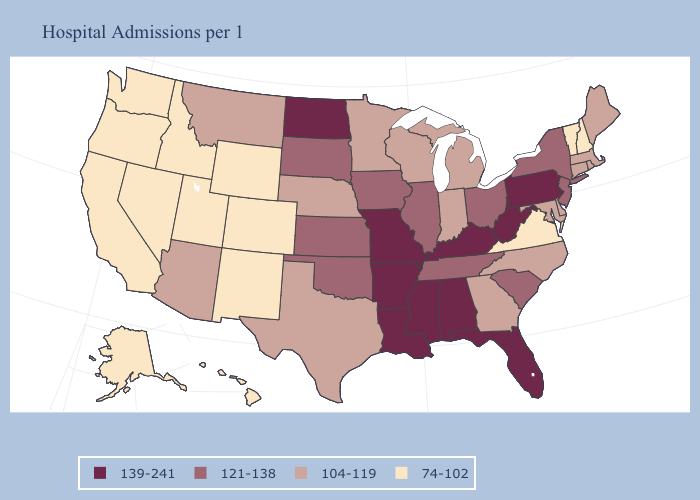Does the map have missing data?
Quick response, please. No. Name the states that have a value in the range 139-241?
Keep it brief. Alabama, Arkansas, Florida, Kentucky, Louisiana, Mississippi, Missouri, North Dakota, Pennsylvania, West Virginia. What is the highest value in states that border Texas?
Quick response, please. 139-241. Name the states that have a value in the range 74-102?
Be succinct. Alaska, California, Colorado, Hawaii, Idaho, Nevada, New Hampshire, New Mexico, Oregon, Utah, Vermont, Virginia, Washington, Wyoming. Is the legend a continuous bar?
Answer briefly. No. Does the map have missing data?
Answer briefly. No. How many symbols are there in the legend?
Quick response, please. 4. What is the highest value in the MidWest ?
Give a very brief answer. 139-241. Name the states that have a value in the range 139-241?
Quick response, please. Alabama, Arkansas, Florida, Kentucky, Louisiana, Mississippi, Missouri, North Dakota, Pennsylvania, West Virginia. Among the states that border California , which have the highest value?
Give a very brief answer. Arizona. Name the states that have a value in the range 104-119?
Write a very short answer. Arizona, Connecticut, Delaware, Georgia, Indiana, Maine, Maryland, Massachusetts, Michigan, Minnesota, Montana, Nebraska, North Carolina, Rhode Island, Texas, Wisconsin. What is the value of Maine?
Quick response, please. 104-119. Among the states that border Arkansas , does Texas have the highest value?
Concise answer only. No. Does the first symbol in the legend represent the smallest category?
Keep it brief. No. Name the states that have a value in the range 139-241?
Be succinct. Alabama, Arkansas, Florida, Kentucky, Louisiana, Mississippi, Missouri, North Dakota, Pennsylvania, West Virginia. 